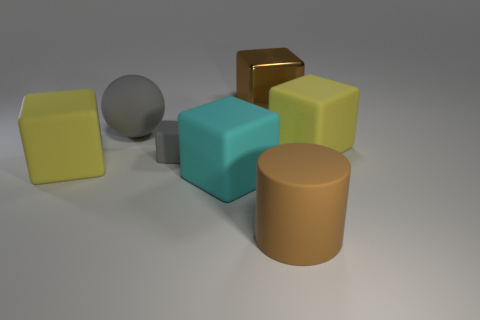The brown rubber thing that is the same size as the shiny thing is what shape?
Make the answer very short. Cylinder. The object on the right side of the cylinder has what shape?
Keep it short and to the point. Cube. Are there fewer yellow cubes behind the big metallic cube than large rubber blocks on the left side of the tiny matte cube?
Give a very brief answer. Yes. There is a brown rubber cylinder; is it the same size as the gray thing behind the small rubber thing?
Offer a very short reply. Yes. How many rubber blocks have the same size as the rubber ball?
Keep it short and to the point. 3. There is a small thing that is made of the same material as the cylinder; what is its color?
Provide a succinct answer. Gray. Is the number of big yellow rubber cubes greater than the number of big cyan matte objects?
Give a very brief answer. Yes. Are the gray ball and the brown cube made of the same material?
Give a very brief answer. No. What is the shape of the tiny thing that is made of the same material as the big cylinder?
Ensure brevity in your answer.  Cube. Is the number of small cubes less than the number of metal cylinders?
Your answer should be compact. No. 